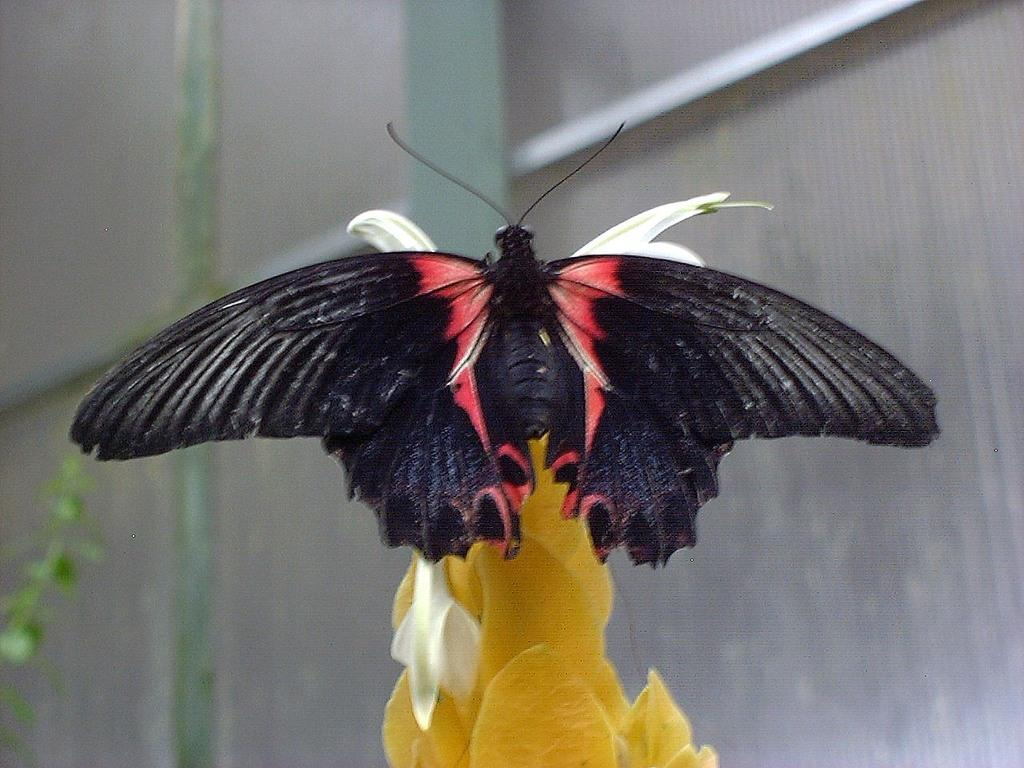What is the main subject of the image? The main subject of the image is a butterfly. Where is the butterfly located in the image? The butterfly is on a flower. What can be seen in the background of the image? There is a plant in the background of the image. What type of thought can be seen in the image? There is no thought present in the image; it features a butterfly on a flower. Is there a tent visible in the image? No, there is no tent present in the image. 